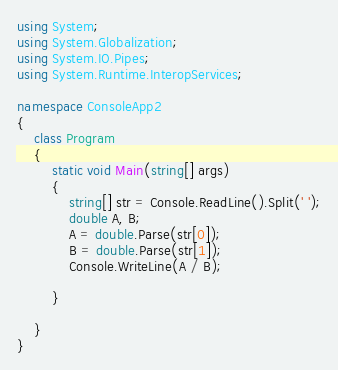<code> <loc_0><loc_0><loc_500><loc_500><_C#_>using System;
using System.Globalization;
using System.IO.Pipes;
using System.Runtime.InteropServices;

namespace ConsoleApp2
{
    class Program
    {
        static void Main(string[] args)
        {
            string[] str = Console.ReadLine().Split(' ');
            double A, B;
            A = double.Parse(str[0]);
            B = double.Parse(str[1]);
            Console.WriteLine(A / B);

        }

    }
}
</code> 